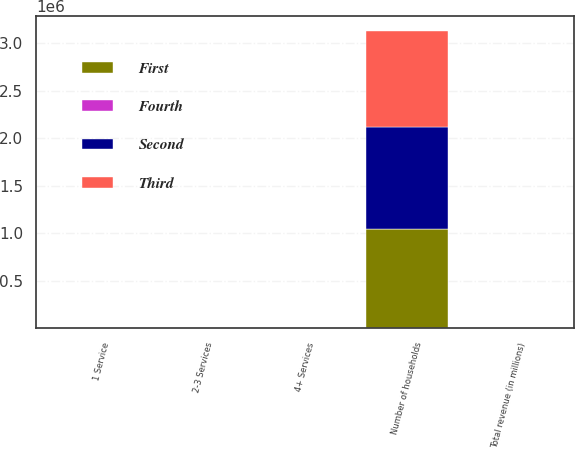Convert chart. <chart><loc_0><loc_0><loc_500><loc_500><stacked_bar_chart><ecel><fcel>Number of households<fcel>1 Service<fcel>2-3 Services<fcel>4+ Services<fcel>Total revenue (in millions)<nl><fcel>Fourth<fcel>71.3<fcel>4.1<fcel>22.4<fcel>73.5<fcel>230.6<nl><fcel>Second<fcel>1.07371e+06<fcel>4.4<fcel>22.8<fcel>72.8<fcel>251.9<nl><fcel>First<fcel>1.04242e+06<fcel>4.5<fcel>24.2<fcel>71.3<fcel>260<nl><fcel>Third<fcel>1.01595e+06<fcel>4.9<fcel>24.6<fcel>70.5<fcel>248.6<nl></chart> 